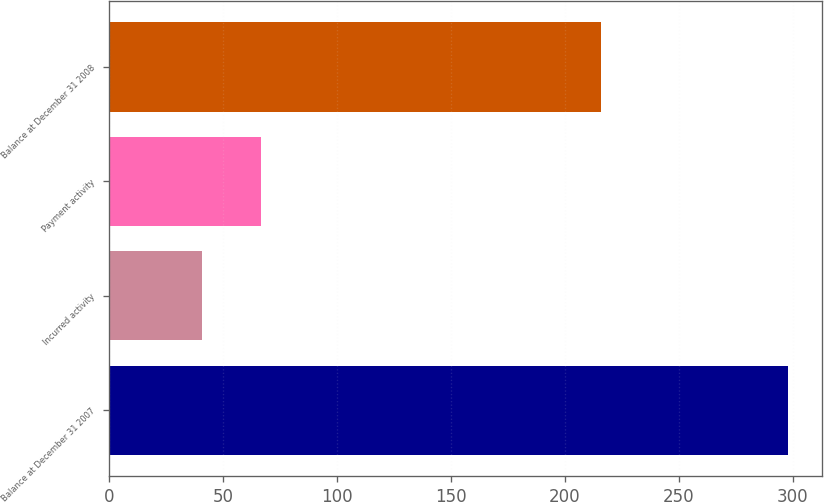<chart> <loc_0><loc_0><loc_500><loc_500><bar_chart><fcel>Balance at December 31 2007<fcel>Incurred activity<fcel>Payment activity<fcel>Balance at December 31 2008<nl><fcel>298<fcel>41<fcel>66.7<fcel>216<nl></chart> 